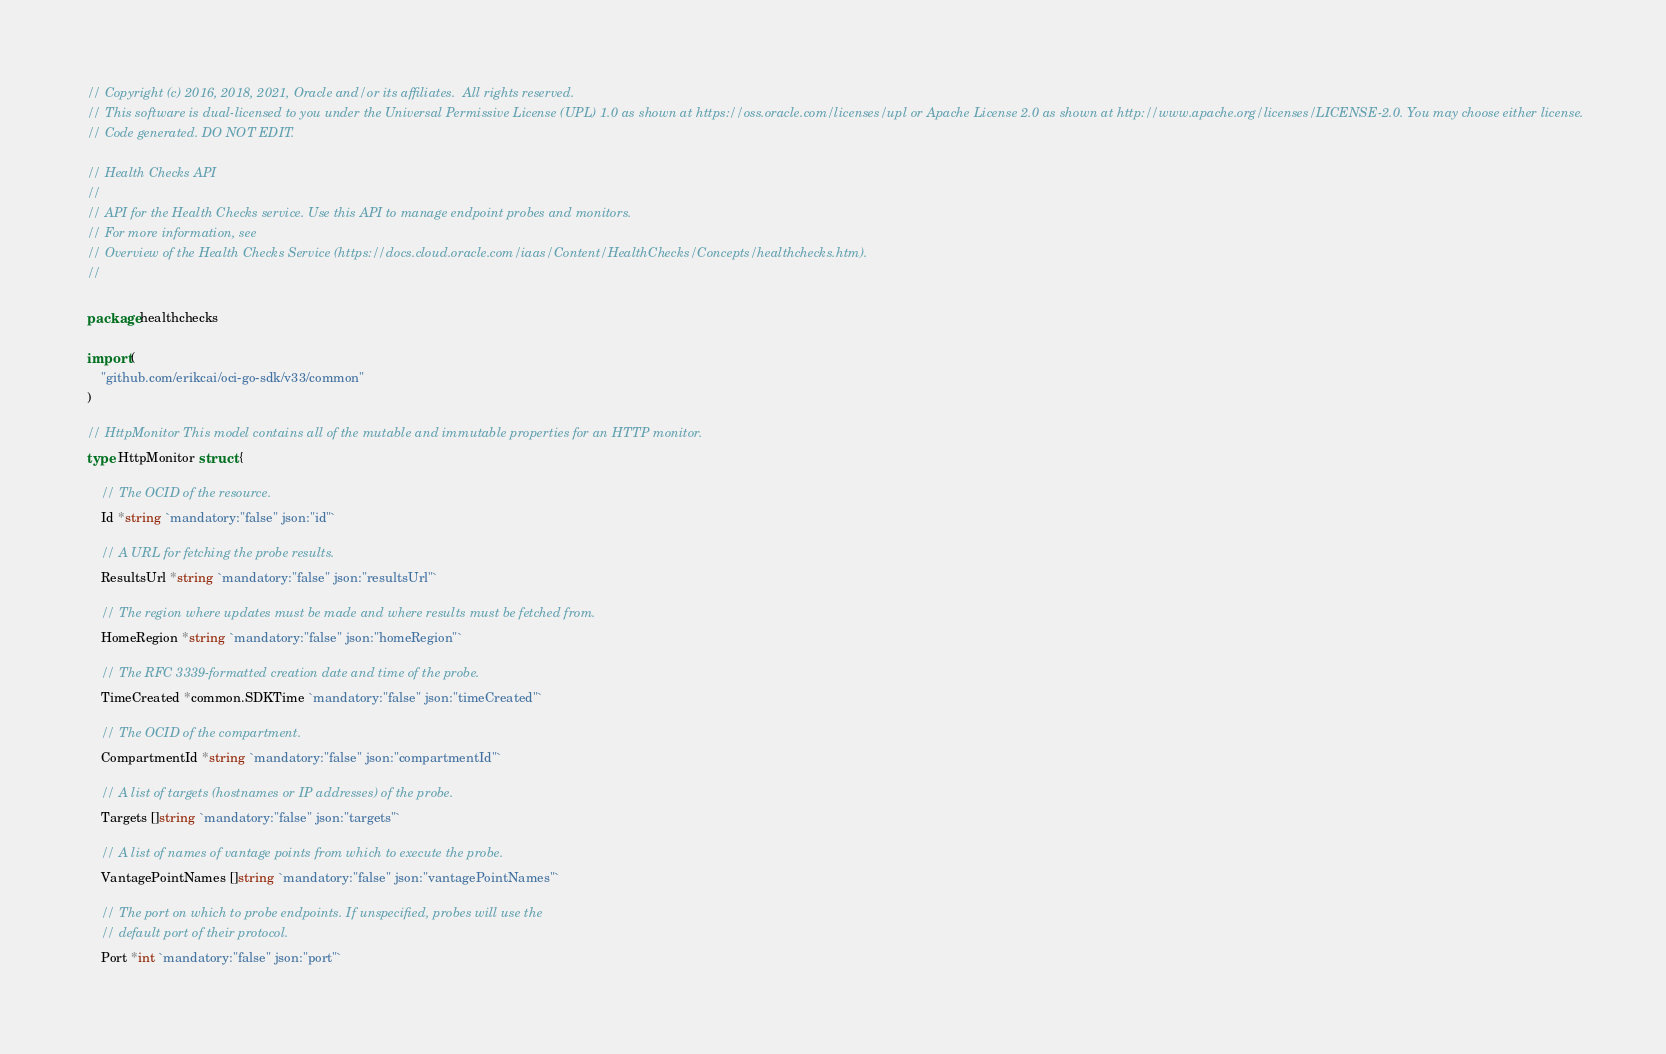Convert code to text. <code><loc_0><loc_0><loc_500><loc_500><_Go_>// Copyright (c) 2016, 2018, 2021, Oracle and/or its affiliates.  All rights reserved.
// This software is dual-licensed to you under the Universal Permissive License (UPL) 1.0 as shown at https://oss.oracle.com/licenses/upl or Apache License 2.0 as shown at http://www.apache.org/licenses/LICENSE-2.0. You may choose either license.
// Code generated. DO NOT EDIT.

// Health Checks API
//
// API for the Health Checks service. Use this API to manage endpoint probes and monitors.
// For more information, see
// Overview of the Health Checks Service (https://docs.cloud.oracle.com/iaas/Content/HealthChecks/Concepts/healthchecks.htm).
//

package healthchecks

import (
	"github.com/erikcai/oci-go-sdk/v33/common"
)

// HttpMonitor This model contains all of the mutable and immutable properties for an HTTP monitor.
type HttpMonitor struct {

	// The OCID of the resource.
	Id *string `mandatory:"false" json:"id"`

	// A URL for fetching the probe results.
	ResultsUrl *string `mandatory:"false" json:"resultsUrl"`

	// The region where updates must be made and where results must be fetched from.
	HomeRegion *string `mandatory:"false" json:"homeRegion"`

	// The RFC 3339-formatted creation date and time of the probe.
	TimeCreated *common.SDKTime `mandatory:"false" json:"timeCreated"`

	// The OCID of the compartment.
	CompartmentId *string `mandatory:"false" json:"compartmentId"`

	// A list of targets (hostnames or IP addresses) of the probe.
	Targets []string `mandatory:"false" json:"targets"`

	// A list of names of vantage points from which to execute the probe.
	VantagePointNames []string `mandatory:"false" json:"vantagePointNames"`

	// The port on which to probe endpoints. If unspecified, probes will use the
	// default port of their protocol.
	Port *int `mandatory:"false" json:"port"`
</code> 